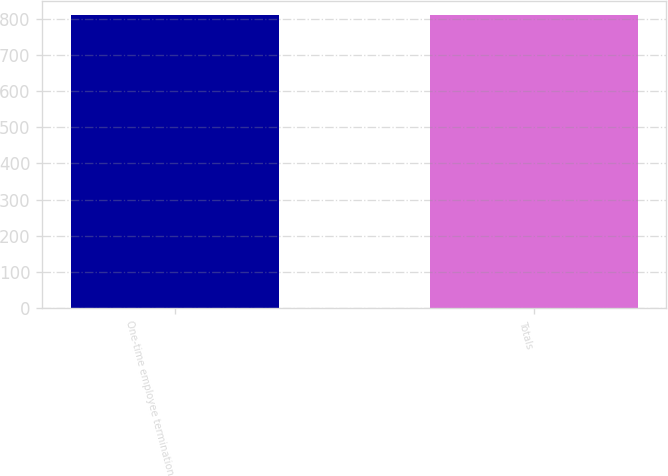Convert chart. <chart><loc_0><loc_0><loc_500><loc_500><bar_chart><fcel>One-time employee termination<fcel>Totals<nl><fcel>809<fcel>809.1<nl></chart> 